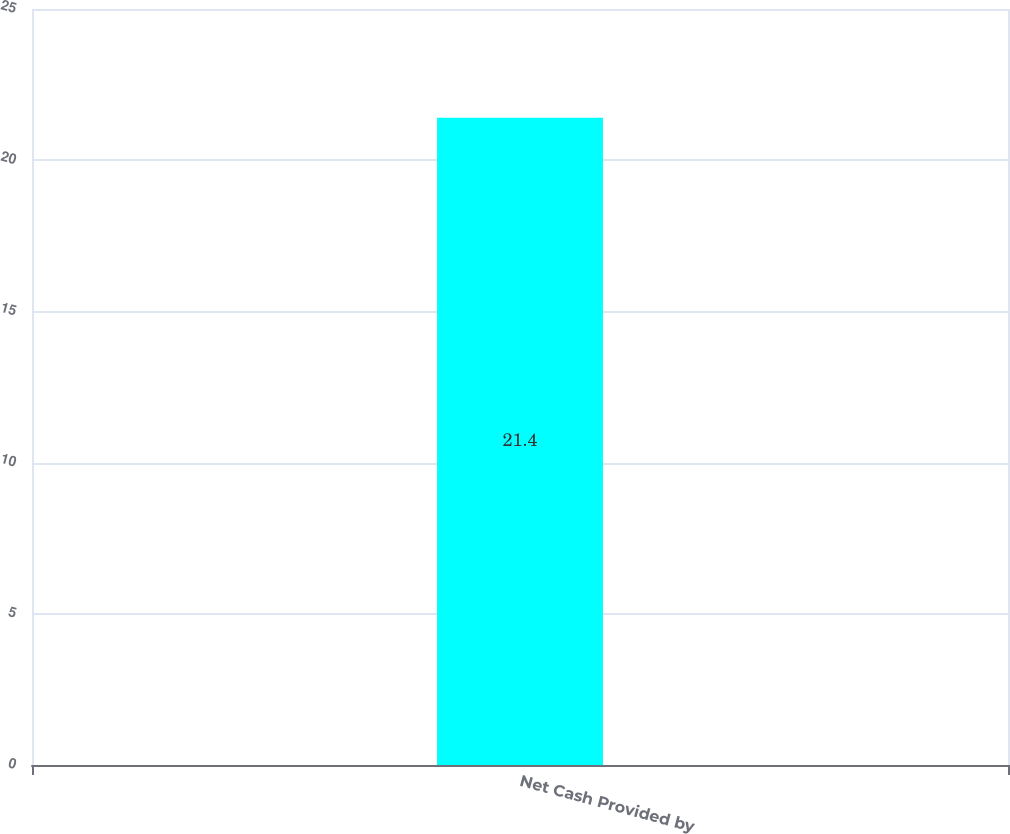<chart> <loc_0><loc_0><loc_500><loc_500><bar_chart><fcel>Net Cash Provided by<nl><fcel>21.4<nl></chart> 